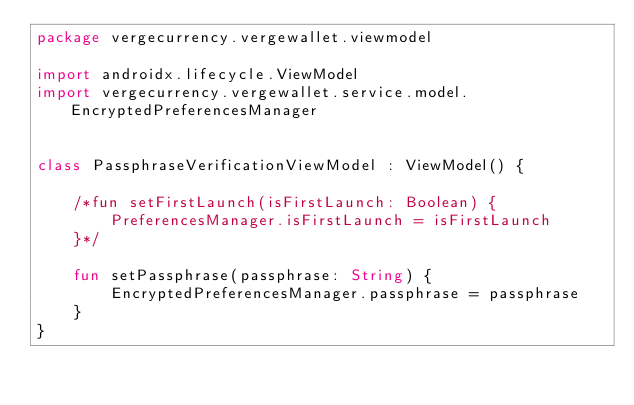Convert code to text. <code><loc_0><loc_0><loc_500><loc_500><_Kotlin_>package vergecurrency.vergewallet.viewmodel

import androidx.lifecycle.ViewModel
import vergecurrency.vergewallet.service.model.EncryptedPreferencesManager


class PassphraseVerificationViewModel : ViewModel() {

    /*fun setFirstLaunch(isFirstLaunch: Boolean) {
        PreferencesManager.isFirstLaunch = isFirstLaunch
    }*/

    fun setPassphrase(passphrase: String) {
        EncryptedPreferencesManager.passphrase = passphrase
    }
}
</code> 